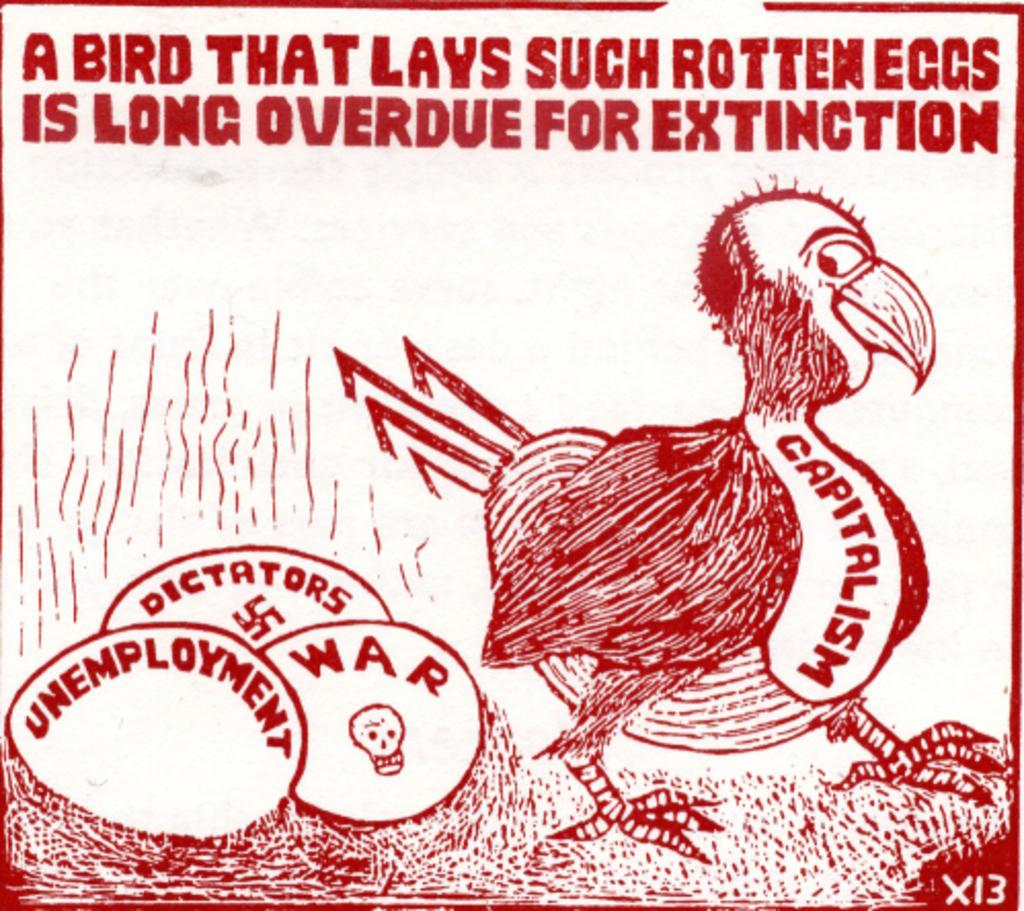What is the color of the poster in the image? The poster is white in the image. What can be found on the poster besides its color? The poster contains images and text in red color. What type of punishment is depicted on the poster in the image? There is no punishment depicted on the poster in the image; it contains images and red text. 